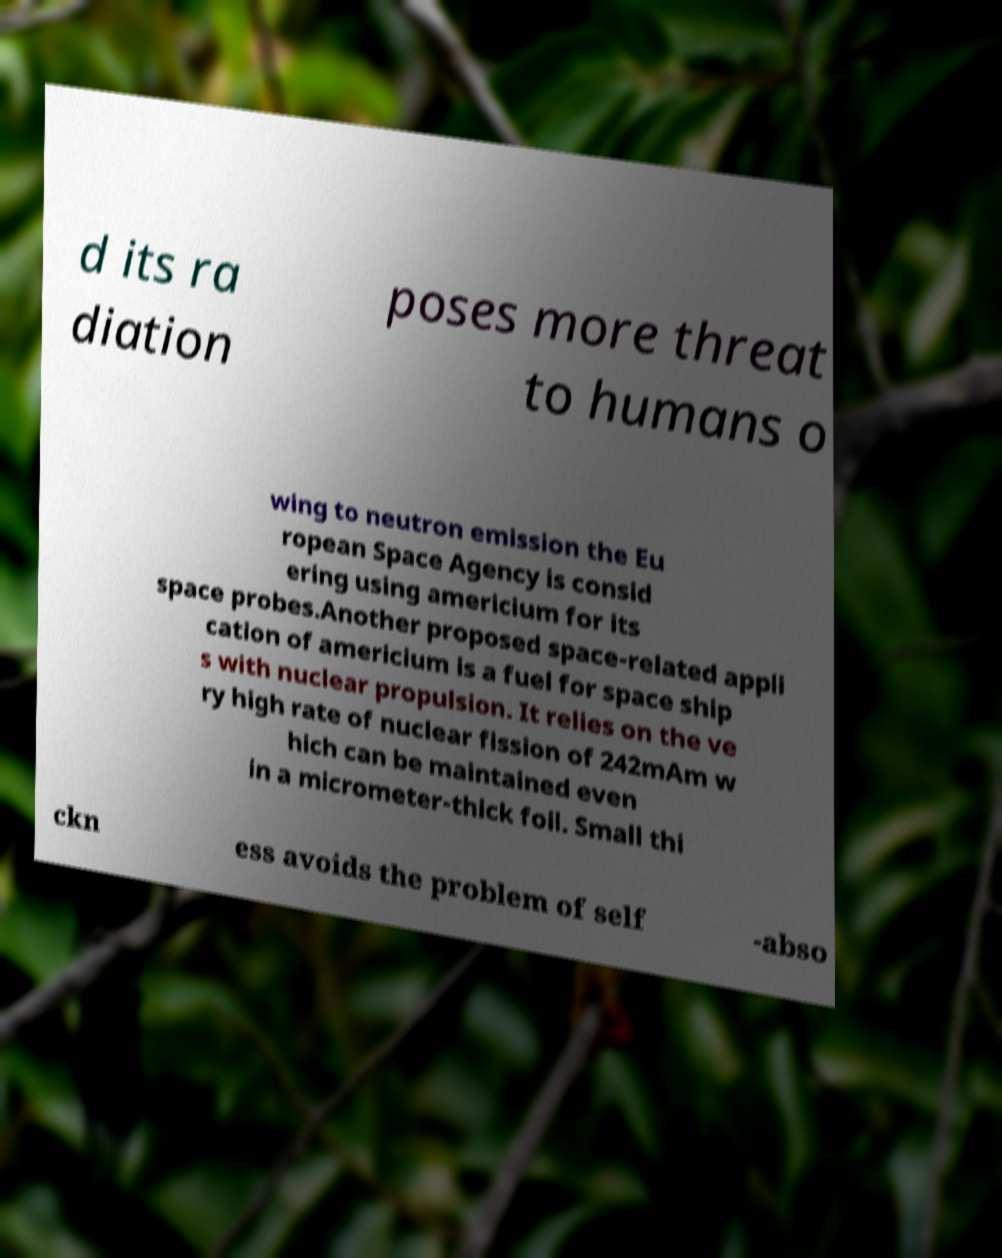Please read and relay the text visible in this image. What does it say? d its ra diation poses more threat to humans o wing to neutron emission the Eu ropean Space Agency is consid ering using americium for its space probes.Another proposed space-related appli cation of americium is a fuel for space ship s with nuclear propulsion. It relies on the ve ry high rate of nuclear fission of 242mAm w hich can be maintained even in a micrometer-thick foil. Small thi ckn ess avoids the problem of self -abso 